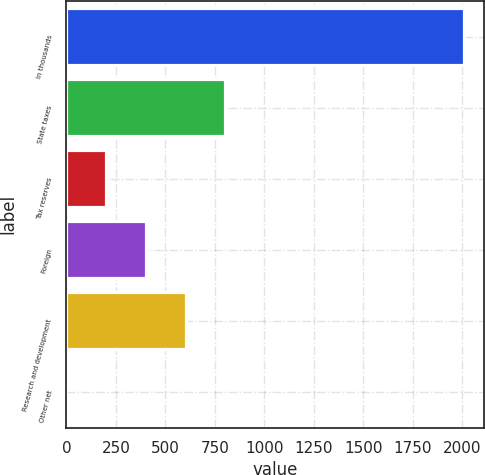Convert chart. <chart><loc_0><loc_0><loc_500><loc_500><bar_chart><fcel>In thousands<fcel>State taxes<fcel>Tax reserves<fcel>Foreign<fcel>Research and development<fcel>Other net<nl><fcel>2008<fcel>803.26<fcel>200.89<fcel>401.68<fcel>602.47<fcel>0.1<nl></chart> 